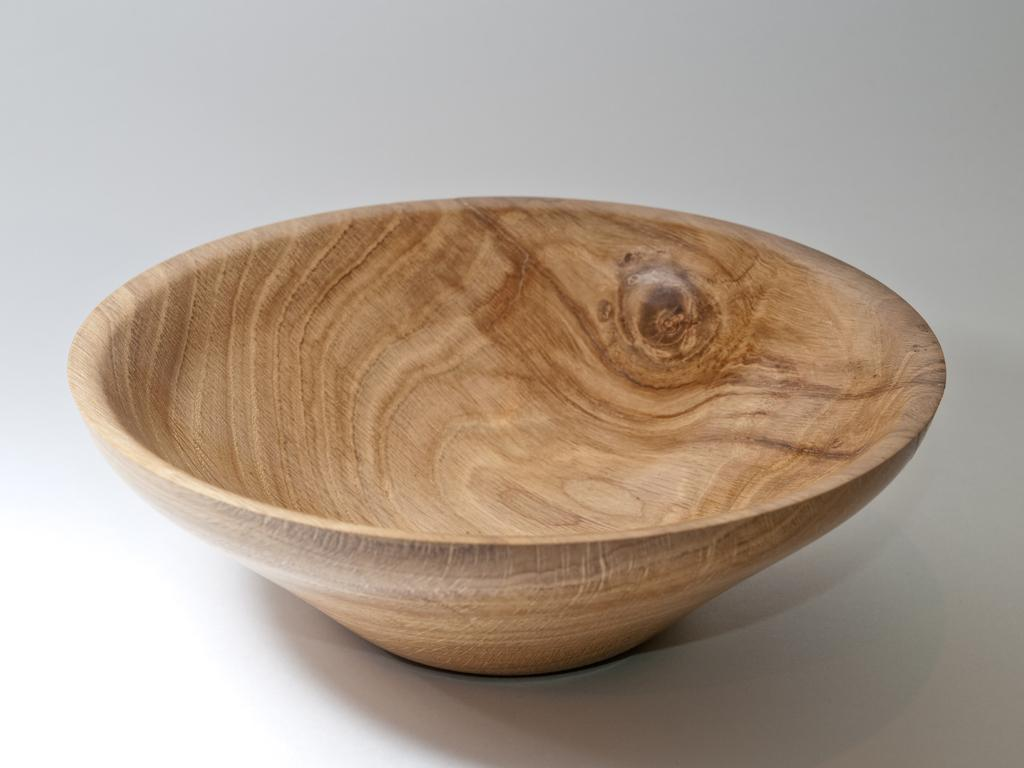What type of material is the bowl made of in the image? There is a wooden bowl in the image. What type of bread can be seen in the quiver in the image? There is no bread or quiver present in the image; it only features a wooden bowl. 